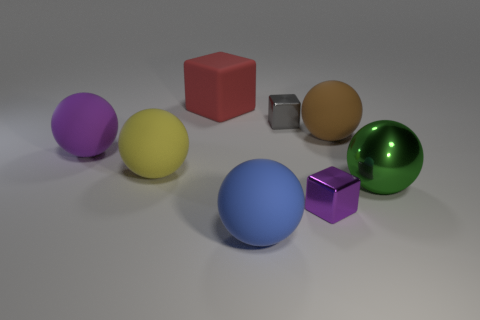Subtract all tiny metal blocks. How many blocks are left? 1 Add 1 green metal spheres. How many objects exist? 9 Subtract all purple spheres. How many spheres are left? 4 Subtract all balls. How many objects are left? 3 Subtract all brown blocks. How many purple balls are left? 1 Subtract all large green shiny things. Subtract all large purple balls. How many objects are left? 6 Add 8 large yellow things. How many large yellow things are left? 9 Add 2 big brown matte spheres. How many big brown matte spheres exist? 3 Subtract 0 purple cylinders. How many objects are left? 8 Subtract 2 balls. How many balls are left? 3 